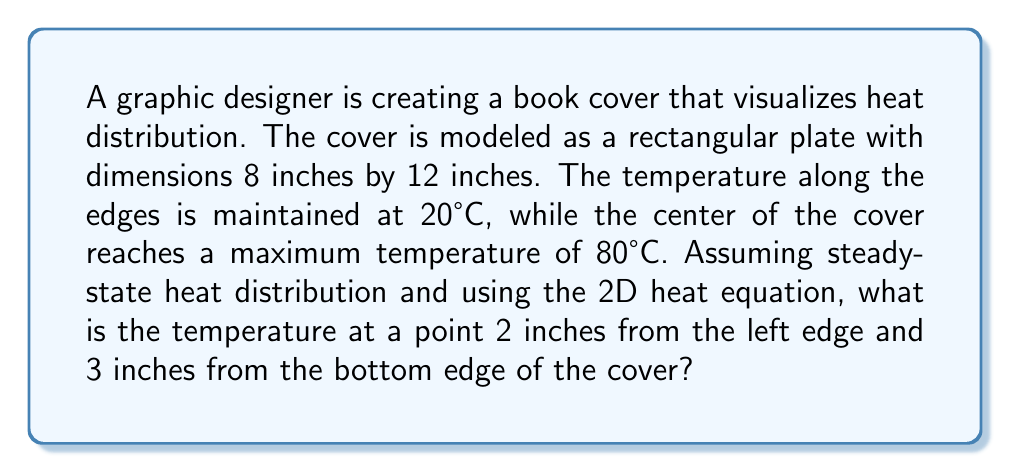Can you answer this question? To solve this problem, we'll use the 2D steady-state heat equation and the given boundary conditions:

1) The 2D steady-state heat equation is:

   $$\frac{\partial^2 T}{\partial x^2} + \frac{\partial^2 T}{\partial y^2} = 0$$

2) Given the boundary conditions and the symmetry of the problem, we can use the solution:

   $$T(x,y) = T_0 + (T_m - T_0)\sin(\frac{\pi x}{L})\sin(\frac{\pi y}{W})$$

   Where:
   $T_0$ = edge temperature (20°C)
   $T_m$ = maximum temperature (80°C)
   $L$ = length (12 inches)
   $W$ = width (8 inches)

3) Substituting the values:

   $$T(x,y) = 20 + 60\sin(\frac{\pi x}{12})\sin(\frac{\pi y}{8})$$

4) For the point (2,3):

   $$T(2,3) = 20 + 60\sin(\frac{\pi \cdot 2}{12})\sin(\frac{\pi \cdot 3}{8})$$

5) Simplifying:

   $$T(2,3) = 20 + 60\sin(\frac{\pi}{6})\sin(\frac{3\pi}{8})$$

6) Calculating:

   $$T(2,3) \approx 20 + 60 \cdot 0.5 \cdot 0.9239 \approx 47.72°C$$
Answer: 47.72°C 